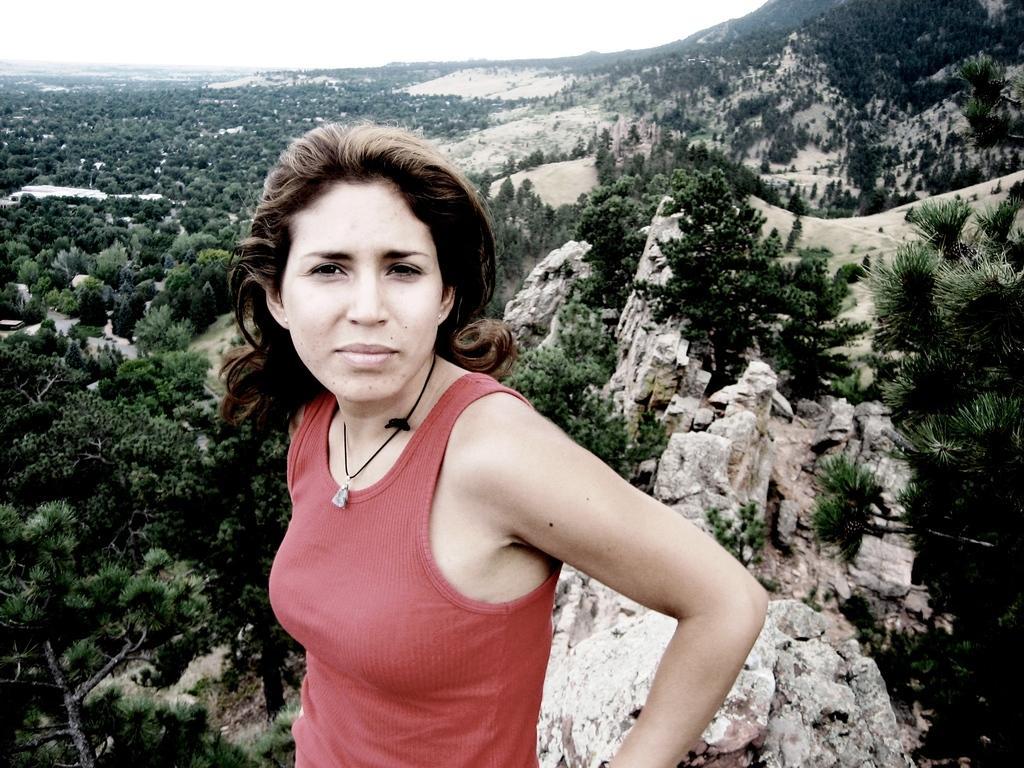How would you summarize this image in a sentence or two? In this image I can see a woman is wearing a red color t-shirt and giving pose for the picture. In the background there are many trees and rocks. At the top of the image I can see the sky. 